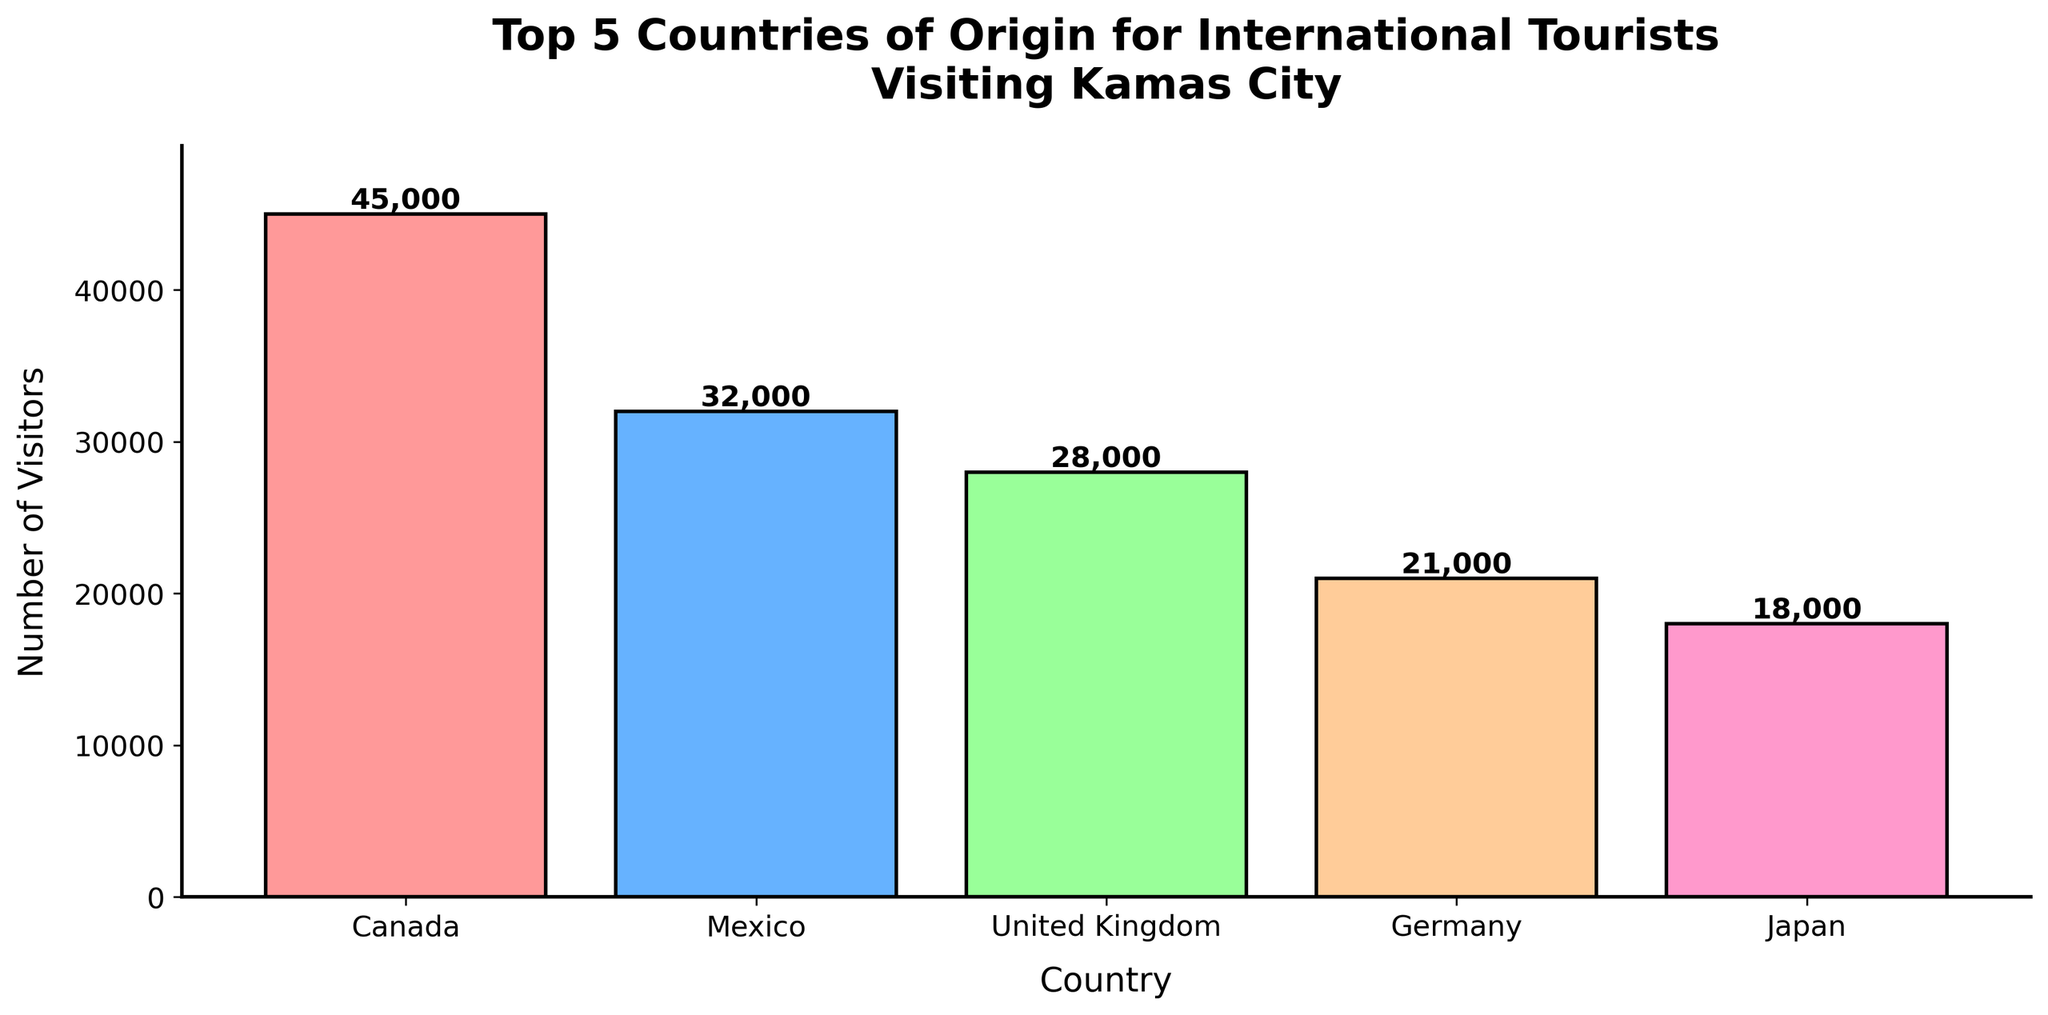What's the total number of visitors from the top 5 countries? Sum the visitors from Canada, Mexico, United Kingdom, Germany, and Japan: 45,000 + 32,000 + 28,000 + 21,000 + 18,000 = 144,000
Answer: 144,000 Which country has the highest number of visitors? Identify the tallest bar, which is labeled as Canada with 45,000 visitors
Answer: Canada How many more visitors does Canada have compared to Germany? Subtract the number of visitors from Germany from that of Canada: 45,000 - 21,000 = 24,000
Answer: 24,000 Which country has the lowest number of visitors among the top 5? Identify the shortest bar, which is labeled as Japan with 18,000 visitors
Answer: Japan What's the average number of visitors from the top 5 countries? Calculate the sum of visitors from the top 5, then divide by 5: (144,000 / 5) = 28,800
Answer: 28,800 What is the difference in the number of visitors between Mexico and the United Kingdom? Subtract the visitors from the United Kingdom from that of Mexico: 32,000 - 28,000 = 4,000
Answer: 4,000 Which countries have more visitors than Japan? Identify countries with a taller bar than Japan: Canada, Mexico, United Kingdom, and Germany
Answer: Canada, Mexico, United Kingdom, Germany How many more visitors does Mexico have compared to Japan and France combined? Combine the visitors from Japan and France, then find the difference from Mexico’s visitors: (18,000 + 15,000) = 33,000; 32,000 - 33,000 = -1,000
Answer: -1,000 What is the median number of visitors among the top 5 countries? Arrange the top 5 visitor numbers in ascending order: 18,000, 21,000, 28,000, 32,000, 45,000. The median is the third value: 28,000
Answer: 28,000 According to the chart, which country has a pink-colored bar? The pink-colored bar is associated with Canada
Answer: Canada 